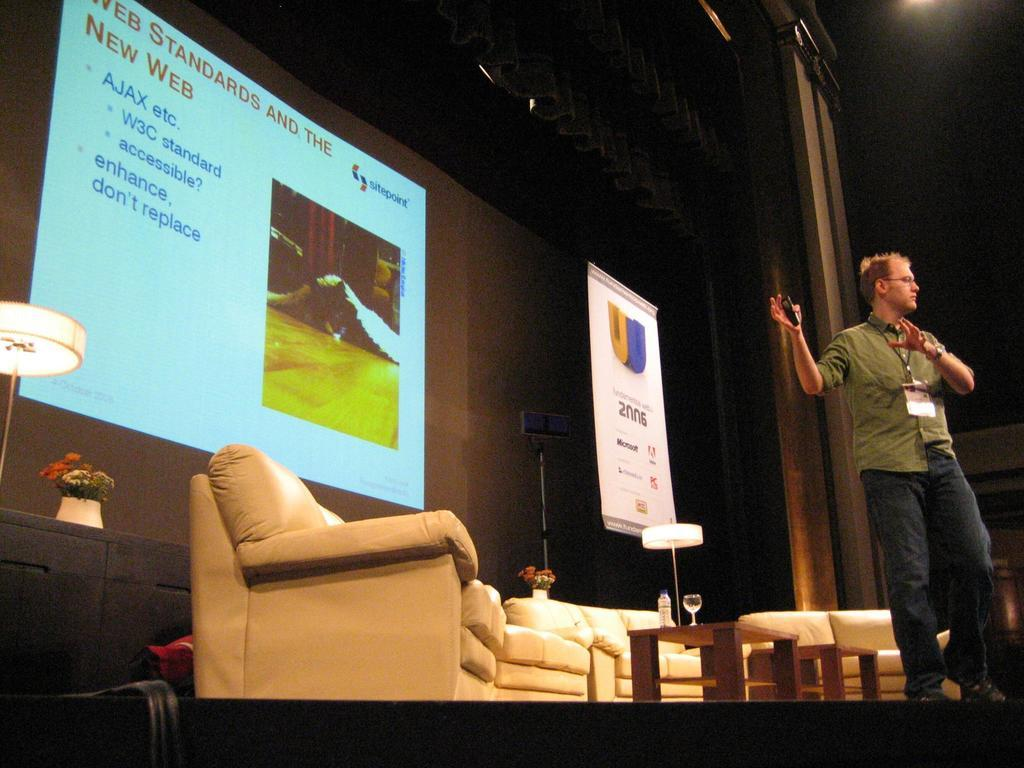What is the man doing in the image? The man is standing in the image. What is the purpose of the projector screen in the image? The projector screen is likely used for presentations or displaying visuals. How many chairs are visible in the image? There are chairs in the image, but the exact number is not specified. What is on the table in the image? There is a water bottle and a wine glass on the table. What type of shirt is the man wearing in the image? The provided facts do not mention the man's shirt, so we cannot determine the type of shirt he is wearing. 